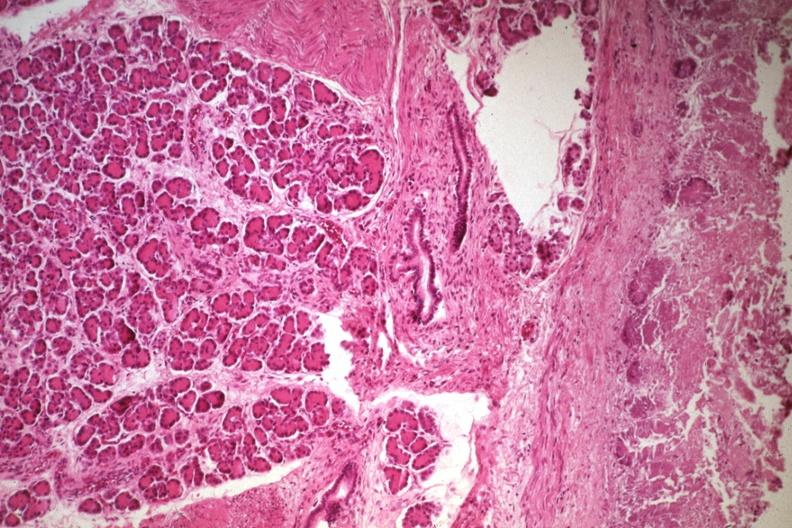s this myoma present?
Answer the question using a single word or phrase. No 